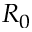Convert formula to latex. <formula><loc_0><loc_0><loc_500><loc_500>R _ { 0 }</formula> 